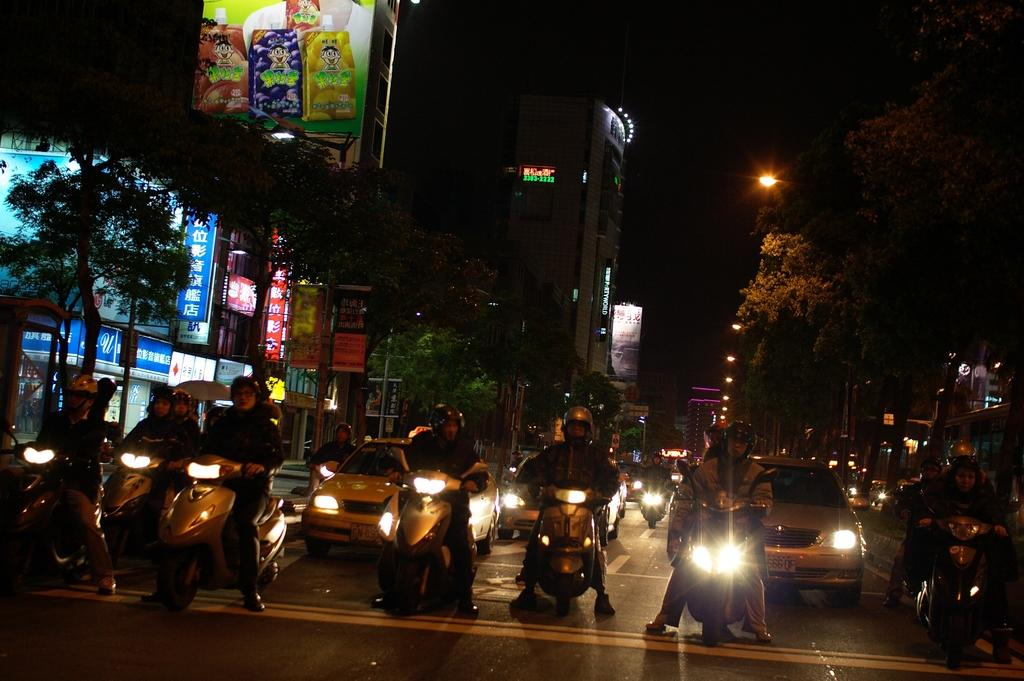What are the main subjects in the center of the image? There are persons on bikes in the center of the image. What other vehicles can be seen in the image? There are cars in the image. What type of natural elements are visible in the background of the image? There are trees in the background of the image. What type of man-made structures are visible in the background of the image? There are buildings in the background of the image. What type of illumination is present in the background of the image? There are lights in the background of the image. What type of signage is present in the background of the image? There are boards with text in the background of the image. What type of ornament is hanging from the pocket of the person on the bike? There is no ornament hanging from the pocket of the person on the bike, as there is no mention of an ornament or pocket in the image. 